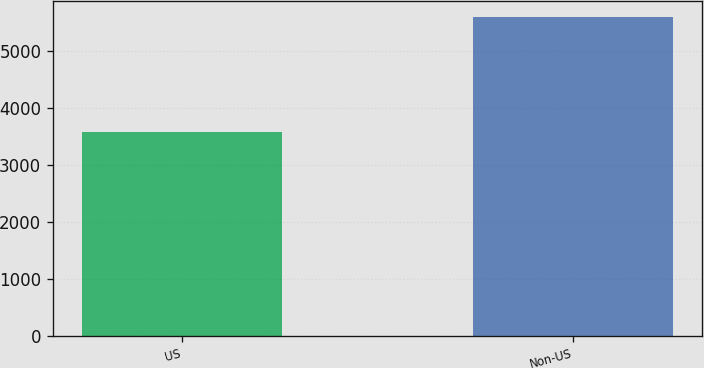Convert chart. <chart><loc_0><loc_0><loc_500><loc_500><bar_chart><fcel>US<fcel>Non-US<nl><fcel>3577<fcel>5600<nl></chart> 